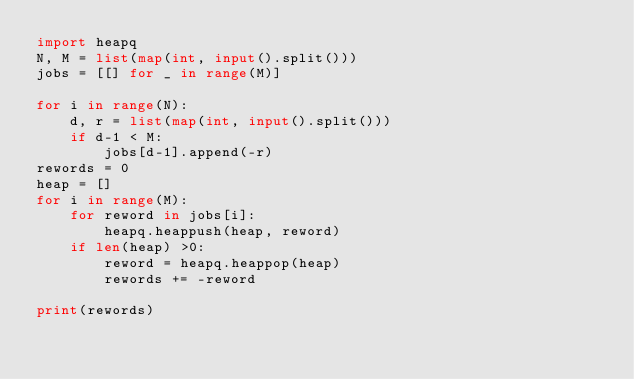<code> <loc_0><loc_0><loc_500><loc_500><_Python_>import heapq
N, M = list(map(int, input().split()))
jobs = [[] for _ in range(M)]

for i in range(N):
    d, r = list(map(int, input().split()))
    if d-1 < M:
        jobs[d-1].append(-r)
rewords = 0
heap = []
for i in range(M):
    for reword in jobs[i]:
        heapq.heappush(heap, reword)
    if len(heap) >0:
        reword = heapq.heappop(heap)
        rewords += -reword

print(rewords)</code> 